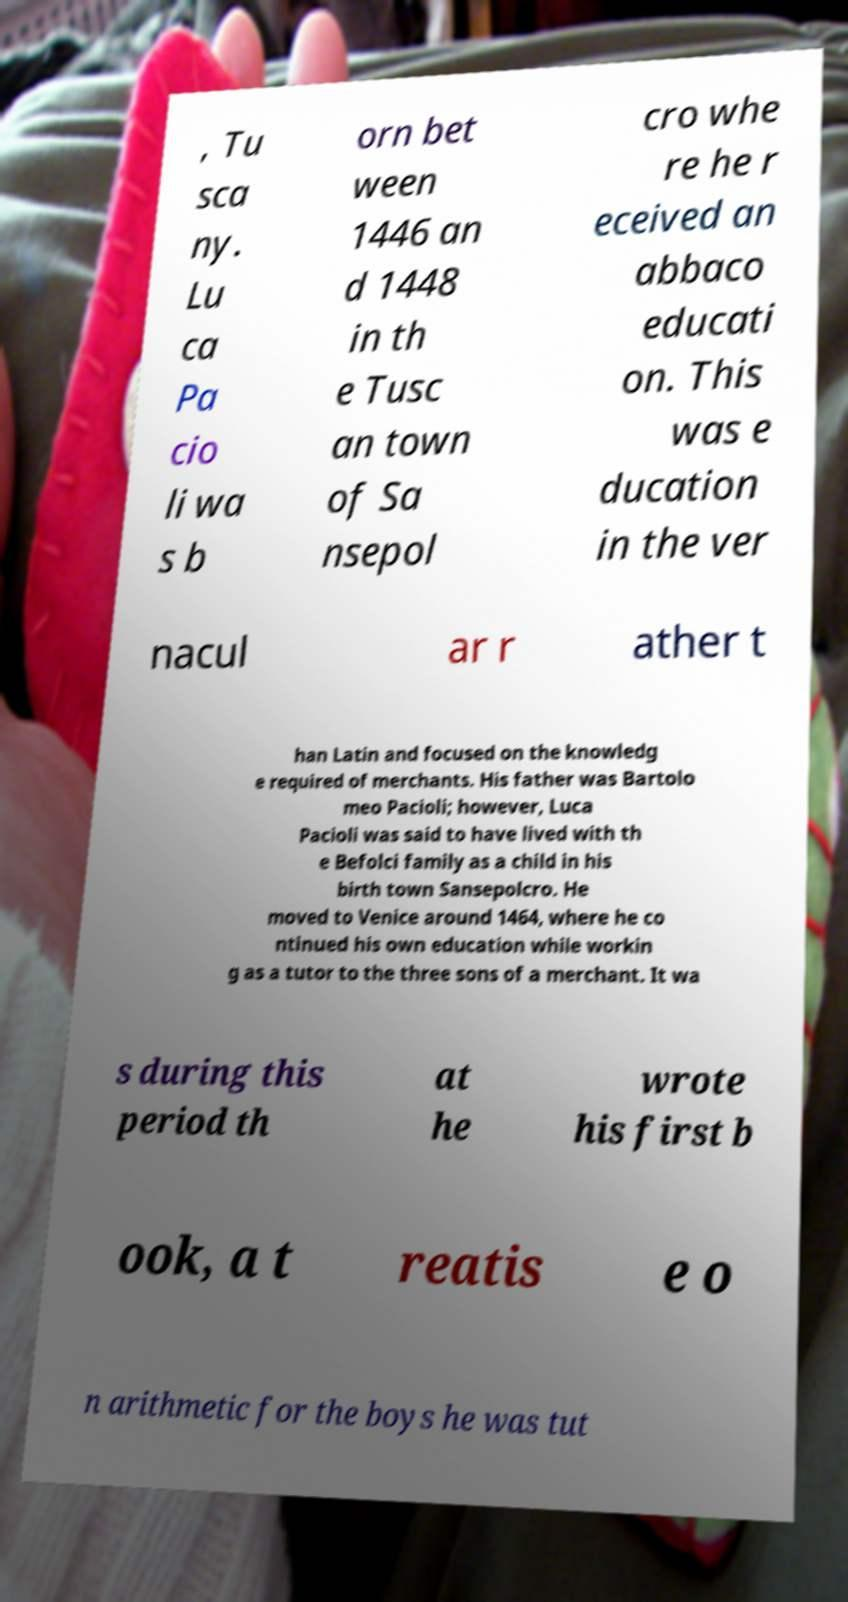Could you assist in decoding the text presented in this image and type it out clearly? , Tu sca ny. Lu ca Pa cio li wa s b orn bet ween 1446 an d 1448 in th e Tusc an town of Sa nsepol cro whe re he r eceived an abbaco educati on. This was e ducation in the ver nacul ar r ather t han Latin and focused on the knowledg e required of merchants. His father was Bartolo meo Pacioli; however, Luca Pacioli was said to have lived with th e Befolci family as a child in his birth town Sansepolcro. He moved to Venice around 1464, where he co ntinued his own education while workin g as a tutor to the three sons of a merchant. It wa s during this period th at he wrote his first b ook, a t reatis e o n arithmetic for the boys he was tut 